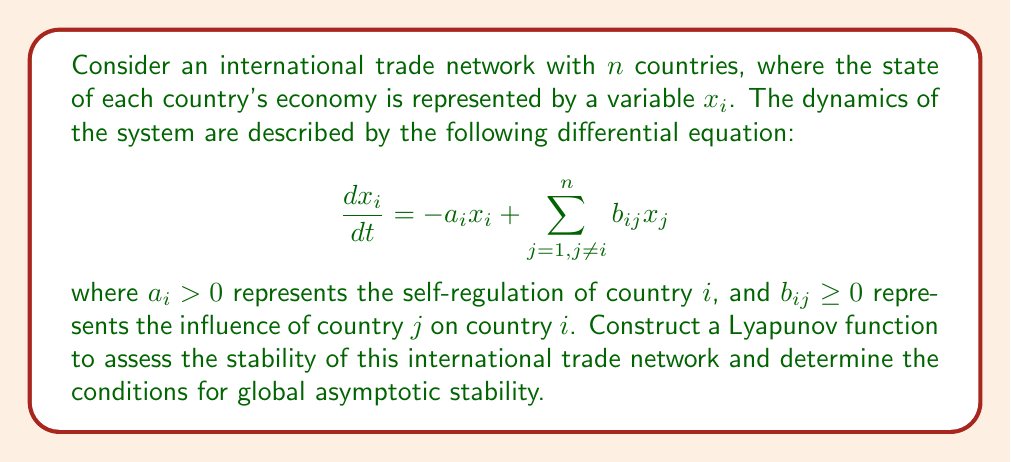Give your solution to this math problem. To assess the stability of the international trade network, we can construct a Lyapunov function and analyze its properties. Let's follow these steps:

1. Propose a candidate Lyapunov function:
   Let's consider a quadratic Lyapunov function of the form:
   
   $$V(x) = \frac{1}{2}\sum_{i=1}^n x_i^2$$

2. Calculate the time derivative of the Lyapunov function:
   
   $$\frac{dV}{dt} = \sum_{i=1}^n x_i\frac{dx_i}{dt}$$
   
   Substituting the system dynamics:
   
   $$\frac{dV}{dt} = \sum_{i=1}^n x_i(-a_ix_i + \sum_{j=1, j\neq i}^n b_{ij}x_j)$$

3. Rearrange the terms:
   
   $$\frac{dV}{dt} = -\sum_{i=1}^n a_ix_i^2 + \sum_{i=1}^n\sum_{j=1, j\neq i}^n b_{ij}x_ix_j$$

4. To ensure stability, we need $\frac{dV}{dt} < 0$ for all $x \neq 0$. This can be guaranteed if:
   
   $$\sum_{i=1}^n a_ix_i^2 > \sum_{i=1}^n\sum_{j=1, j\neq i}^n b_{ij}x_ix_j$$

5. We can use the Cauchy-Schwarz inequality to bound the right-hand side:
   
   $$\sum_{i=1}^n\sum_{j=1, j\neq i}^n b_{ij}x_ix_j \leq \frac{1}{2}\sum_{i=1}^n\sum_{j=1, j\neq i}^n b_{ij}(x_i^2 + x_j^2)$$

6. Rearranging the terms:
   
   $$\frac{1}{2}\sum_{i=1}^n\sum_{j=1, j\neq i}^n b_{ij}(x_i^2 + x_j^2) = \sum_{i=1}^n (\sum_{j=1, j\neq i}^n b_{ij})x_i^2$$

7. Therefore, the condition for global asymptotic stability becomes:
   
   $$a_i > \sum_{j=1, j\neq i}^n b_{ij} \quad \text{for all } i = 1, 2, ..., n$$

This condition implies that the self-regulation of each country should be stronger than the sum of all influences from other countries.
Answer: The Lyapunov function $V(x) = \frac{1}{2}\sum_{i=1}^n x_i^2$ assesses the stability of the international trade network. The system is globally asymptotically stable if $a_i > \sum_{j=1, j\neq i}^n b_{ij}$ for all $i = 1, 2, ..., n$. 